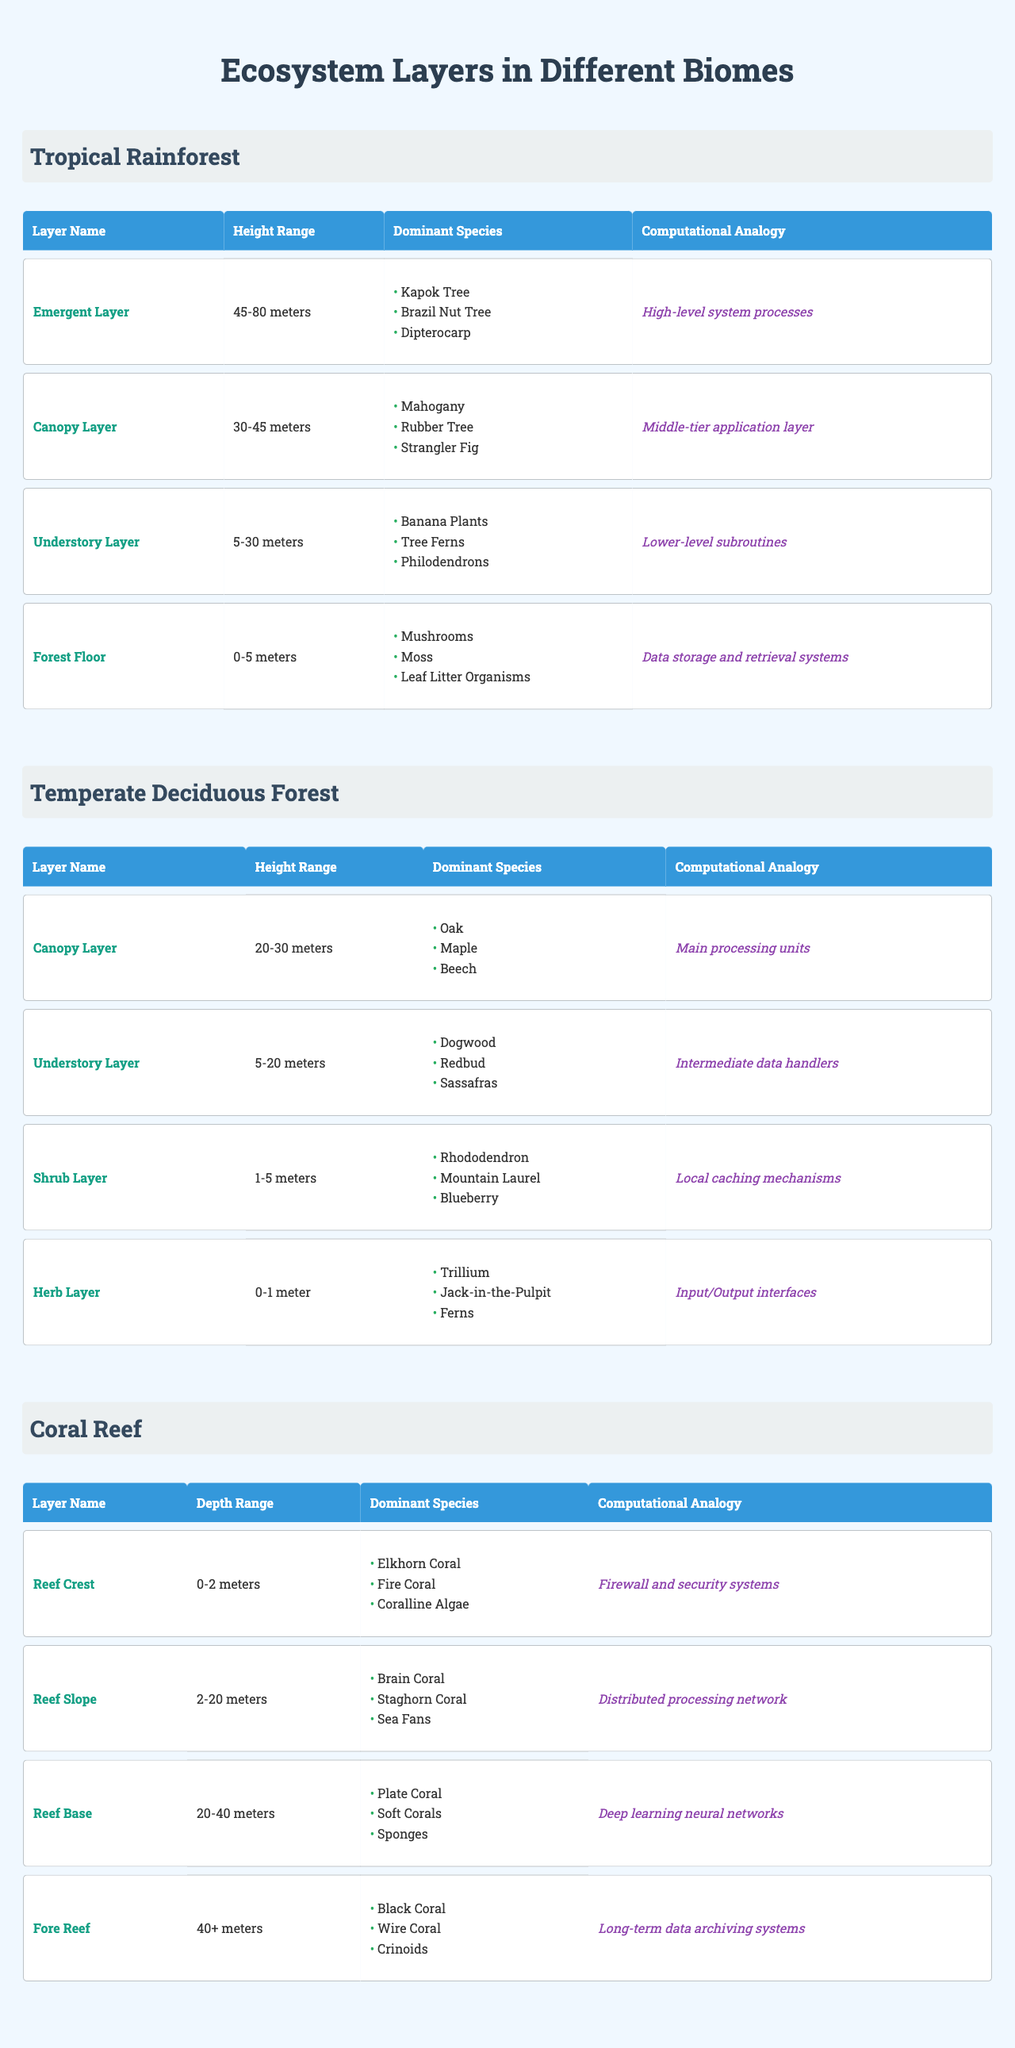What is the height range of the Canopy Layer in the Tropical Rainforest? The Canopy Layer in the Tropical Rainforest has a height range listed in the table as 30-45 meters.
Answer: 30-45 meters What are the dominant species in the Emergent Layer of the Tropical Rainforest? The table lists the dominant species in the Emergent Layer as Kapok Tree, Brazil Nut Tree, and Dipterocarp.
Answer: Kapok Tree, Brazil Nut Tree, Dipterocarp Which biome has the highest dominant species in the Understory Layer? Comparing the Understory Layers of the different biomes, the Tropical Rainforest lists Banana Plants, Tree Ferns, and Philodendrons, while Temperate Deciduous Forest lists Dogwood, Redbud, and Sassafras; thus, no direct comparison is made. However, the Tropical Rainforest usually has a richer biodiversity overall.
Answer: Tropical Rainforest Is the Forest Floor in the Tropical Rainforest deeper than the Herb Layer in the Temperate Deciduous Forest? The Forest Floor in the Tropical Rainforest has a height range of 0-5 meters, while the Herb Layer in the Temperate Deciduous Forest has a height range of 0-1 meter. Since 5 meters is deeper than 1 meter, the answer is yes.
Answer: Yes How many layers are there in the Coral Reef biome, and what is their dominant species? The Coral Reef biome contains four layers: Reef Crest (Elkhorn Coral, Fire Coral, Coralline Algae), Reef Slope (Brain Coral, Staghorn Coral, Sea Fans), Reef Base (Plate Coral, Soft Corals, Sponges), and Fore Reef (Black Coral, Wire Coral, Crinoids). Hence, there are four layers in total.
Answer: Four layers What is the average height range of the Understory Layer across the Tropical Rainforest and Temperate Deciduous Forest? The Understory Layer in the Tropical Rainforest ranges from 5-30 meters, and in the Temperate Deciduous Forest, it ranges from 5-20 meters. To calculate the average: (30 + 20)/2 for max range = 25 meters, and for min range, it’s (5 + 5)/2 = 5 meters. Therefore, the average height range is 5-25 meters.
Answer: 5-25 meters Does the Canopy Layer of the Temperate Deciduous Forest contain any dominant species that are also found in the Coral Reef biome? The dominant species in the Canopy Layer of the Temperate Deciduous Forest are Oak, Maple, and Beech, while the Coral Reef's dominant species consist of corals and algae, which do not overlap. Thus, the answer is no.
Answer: No Which biome's layers include a term referring to data storage and retrieval systems? The Forest Floor of the Tropical Rainforest has the computational analogy of "Data storage and retrieval systems" as per the table.
Answer: Tropical Rainforest What might the computational analogy of the Reef Crest layer signify in a technological context? The Reef Crest, with "Firewall and security systems," signifies protection and security measures in technology, much like a firewall does in computer systems.
Answer: Firewall and security systems 